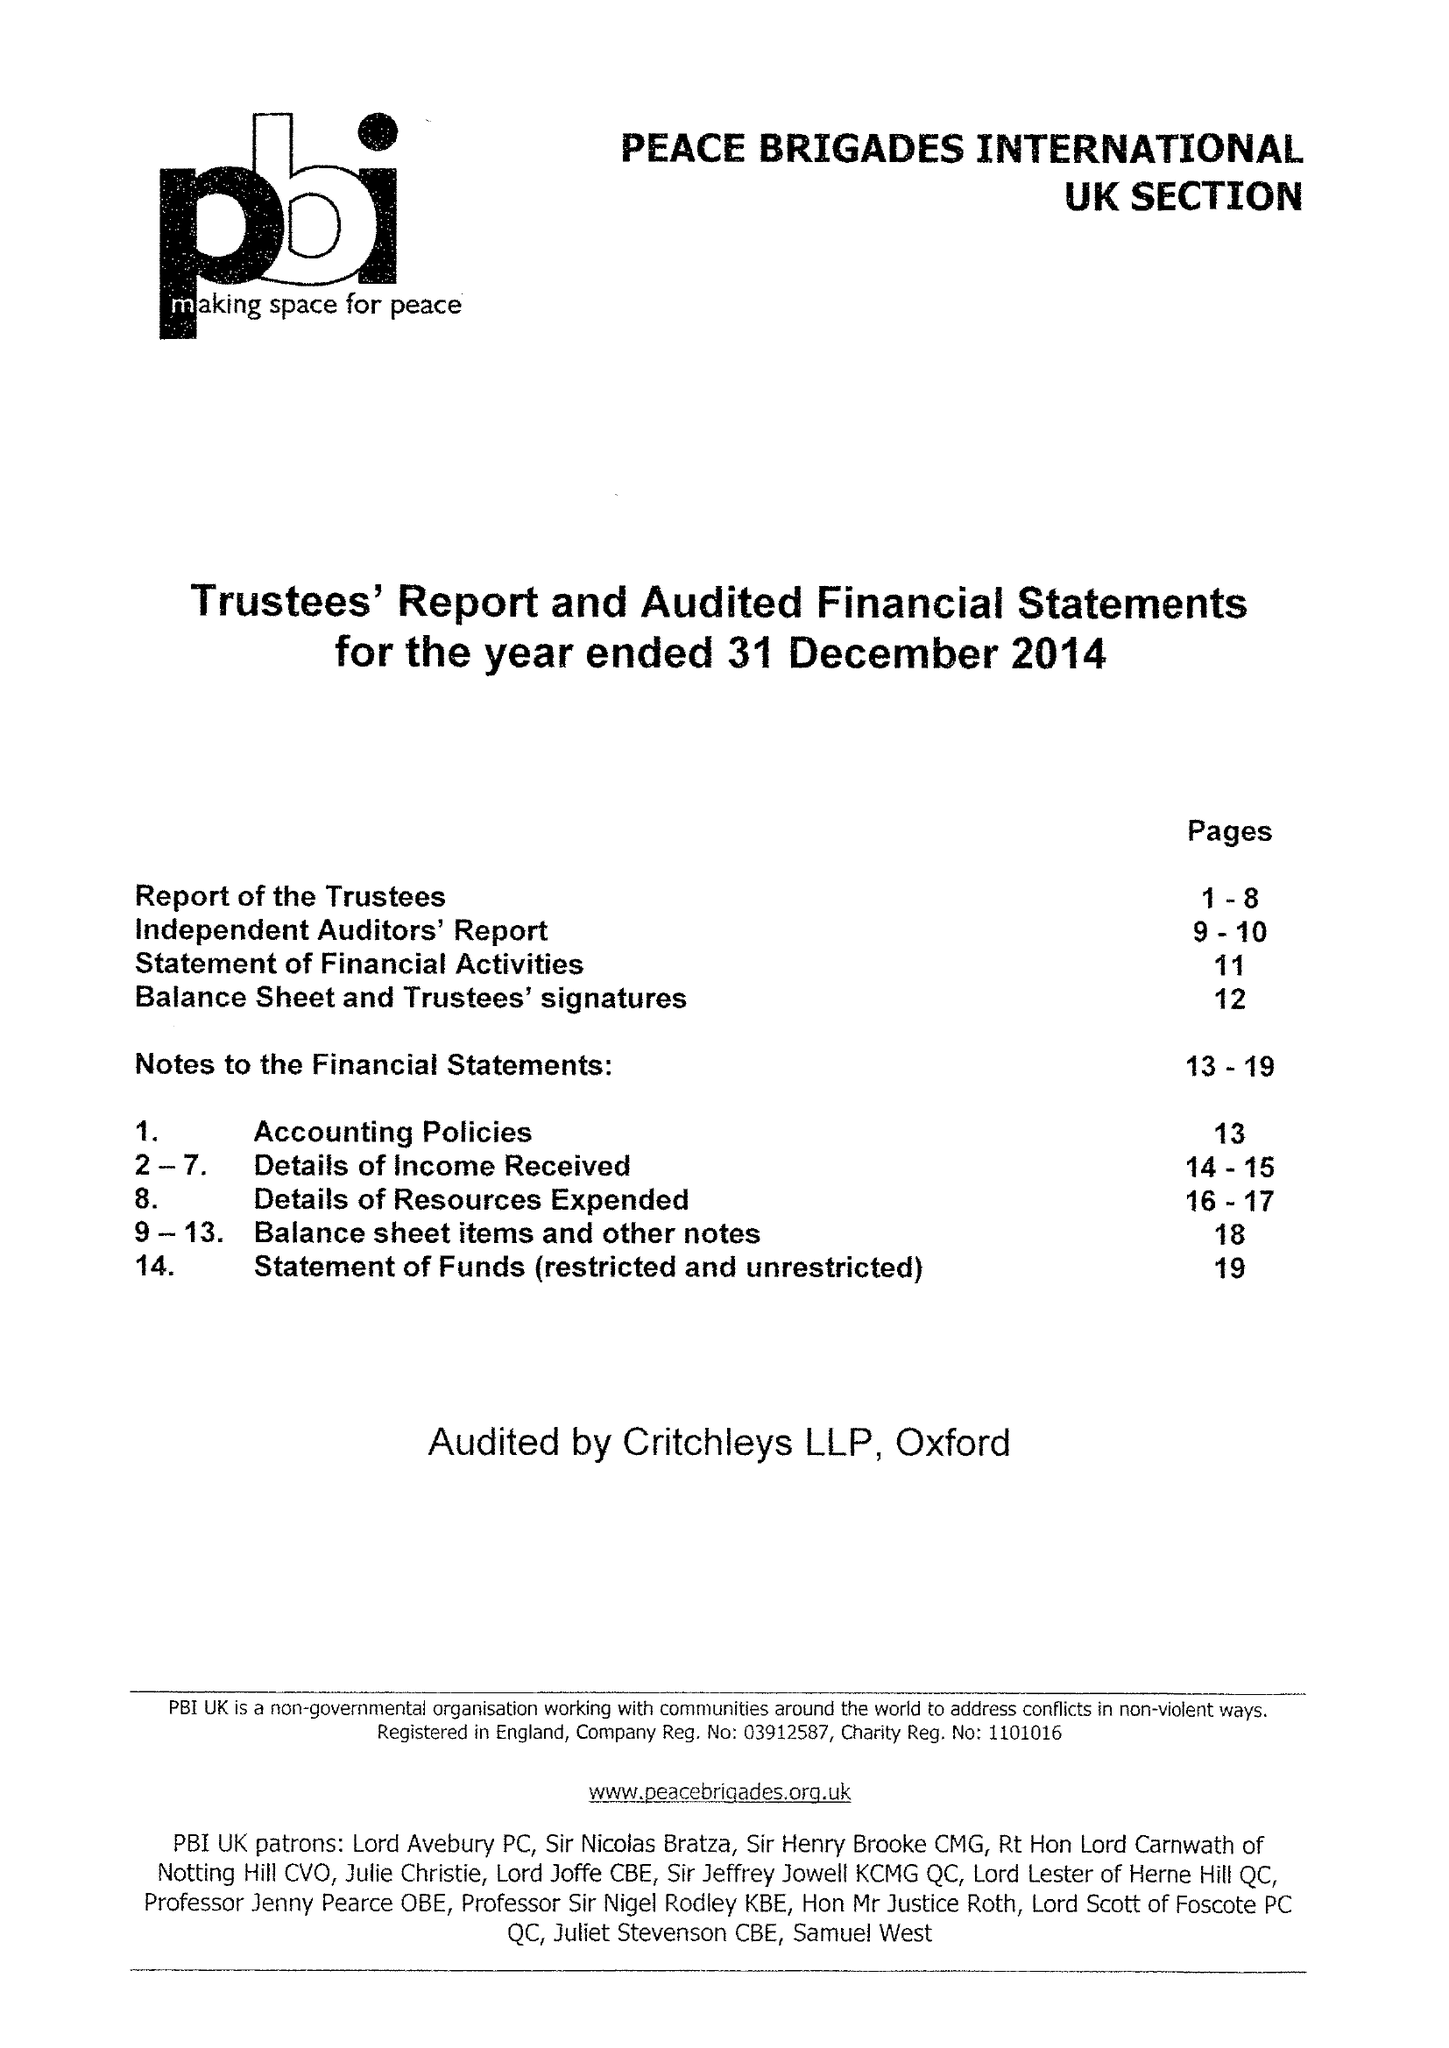What is the value for the income_annually_in_british_pounds?
Answer the question using a single word or phrase. 342580.00 